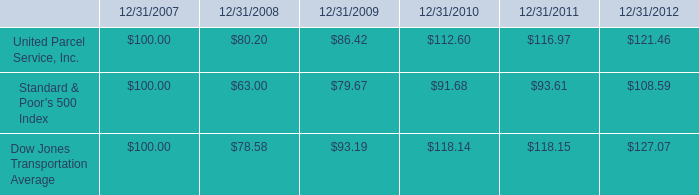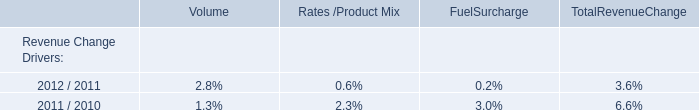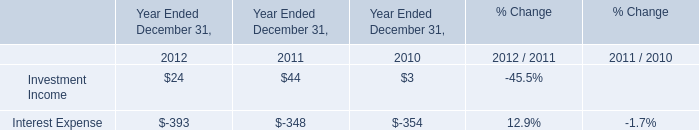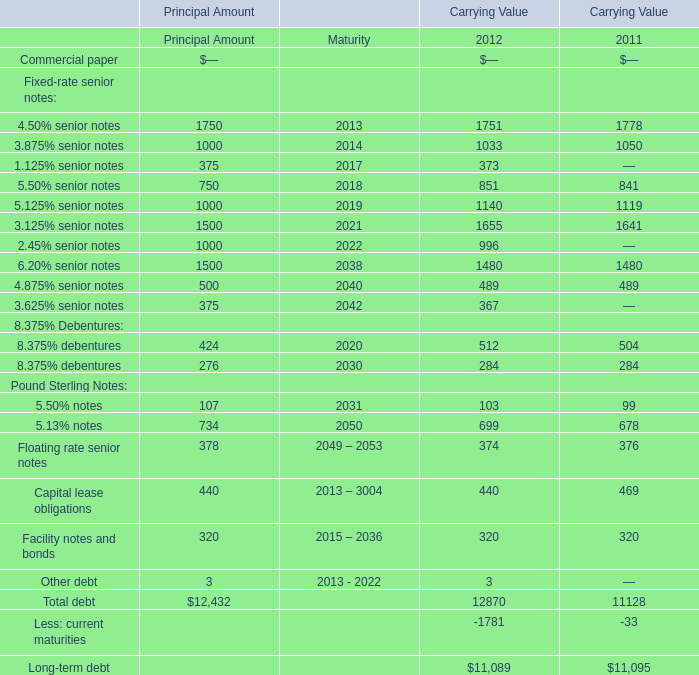What is the growing rate of Investment Income in Table 2 in the years with the least 5.125% senior notes of Carrying Value in Table 3? 
Computations: ((44 - 3) / 3)
Answer: 13.66667. 